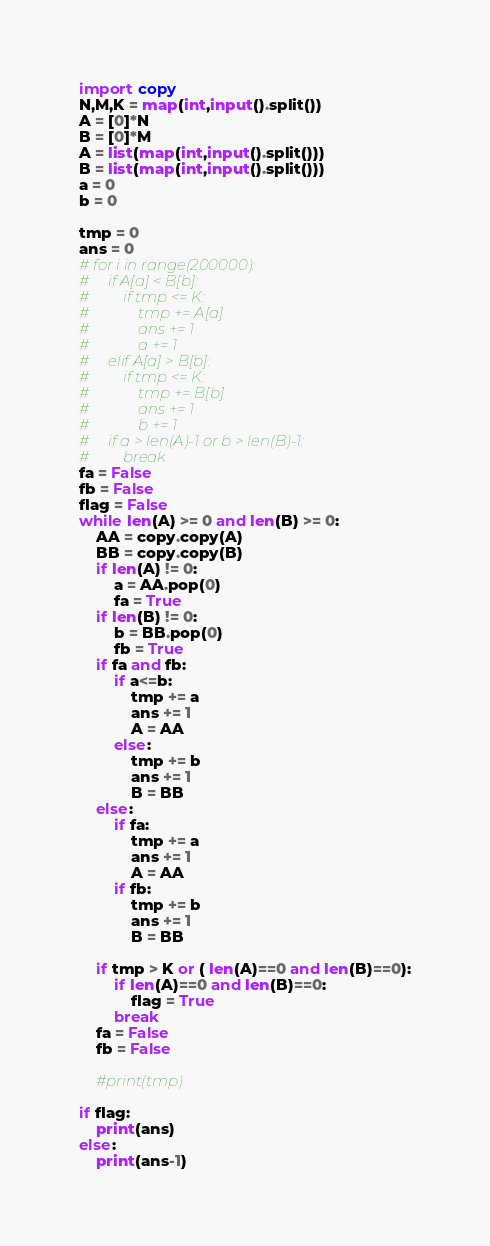<code> <loc_0><loc_0><loc_500><loc_500><_Python_>import copy
N,M,K = map(int,input().split())
A = [0]*N
B = [0]*M
A = list(map(int,input().split()))
B = list(map(int,input().split()))
a = 0
b = 0

tmp = 0
ans = 0
# for i in range(200000):
#     if A[a] < B[b]:
#         if tmp <= K:
#             tmp += A[a]
#             ans += 1
#             a += 1
#     elif A[a] > B[b]:
#         if tmp <= K:
#             tmp += B[b]
#             ans += 1
#             b += 1
#     if a > len(A)-1 or b > len(B)-1:
#         break
fa = False
fb = False
flag = False
while len(A) >= 0 and len(B) >= 0:
    AA = copy.copy(A)
    BB = copy.copy(B)
    if len(A) != 0:
        a = AA.pop(0)
        fa = True
    if len(B) != 0:
        b = BB.pop(0)
        fb = True
    if fa and fb:
        if a<=b:
            tmp += a
            ans += 1
            A = AA
        else:
            tmp += b
            ans += 1
            B = BB
    else:
        if fa:
            tmp += a
            ans += 1
            A = AA
        if fb:
            tmp += b
            ans += 1
            B = BB

    if tmp > K or ( len(A)==0 and len(B)==0):
        if len(A)==0 and len(B)==0:
            flag = True
        break
    fa = False
    fb = False
    
    #print(tmp)
    
if flag:
    print(ans)
else:
    print(ans-1)
</code> 